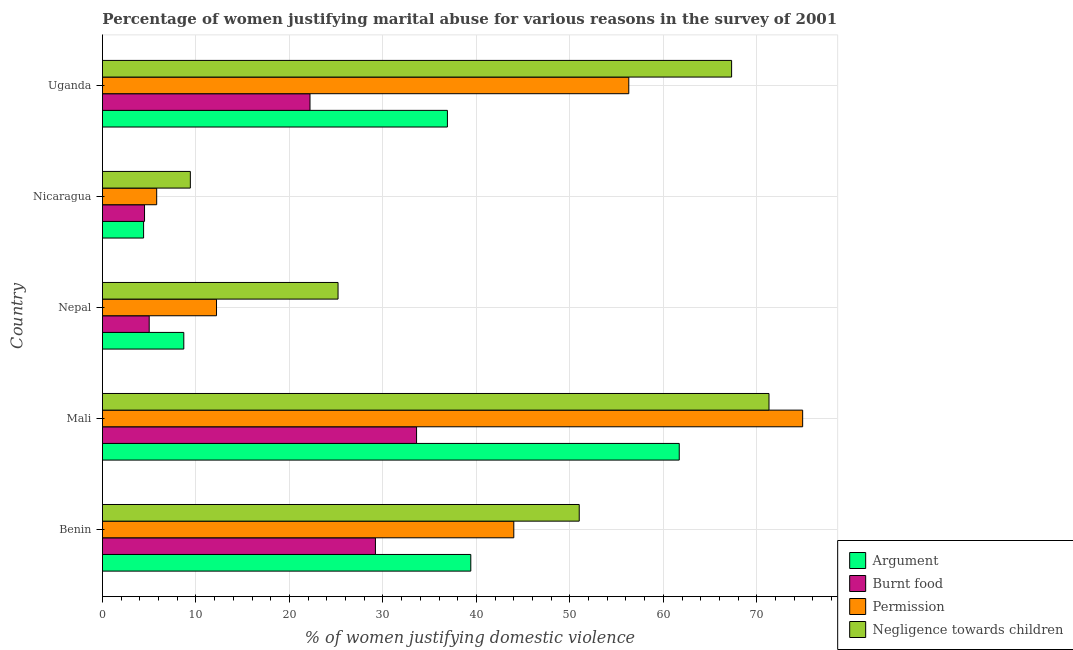How many groups of bars are there?
Provide a short and direct response. 5. Are the number of bars on each tick of the Y-axis equal?
Provide a short and direct response. Yes. How many bars are there on the 3rd tick from the top?
Your response must be concise. 4. What is the label of the 3rd group of bars from the top?
Offer a very short reply. Nepal. In how many cases, is the number of bars for a given country not equal to the number of legend labels?
Provide a short and direct response. 0. What is the percentage of women justifying abuse for showing negligence towards children in Nepal?
Provide a succinct answer. 25.2. Across all countries, what is the maximum percentage of women justifying abuse for going without permission?
Ensure brevity in your answer.  74.9. Across all countries, what is the minimum percentage of women justifying abuse for burning food?
Your answer should be very brief. 4.5. In which country was the percentage of women justifying abuse for going without permission maximum?
Make the answer very short. Mali. In which country was the percentage of women justifying abuse in the case of an argument minimum?
Offer a terse response. Nicaragua. What is the total percentage of women justifying abuse for going without permission in the graph?
Offer a terse response. 193.2. What is the difference between the percentage of women justifying abuse in the case of an argument in Nicaragua and that in Uganda?
Give a very brief answer. -32.5. What is the difference between the percentage of women justifying abuse for burning food in Benin and the percentage of women justifying abuse for going without permission in Nicaragua?
Offer a very short reply. 23.4. What is the average percentage of women justifying abuse for going without permission per country?
Keep it short and to the point. 38.64. What is the ratio of the percentage of women justifying abuse for burning food in Nepal to that in Nicaragua?
Ensure brevity in your answer.  1.11. Is the percentage of women justifying abuse for burning food in Benin less than that in Nicaragua?
Provide a succinct answer. No. What is the difference between the highest and the second highest percentage of women justifying abuse for burning food?
Provide a succinct answer. 4.4. What is the difference between the highest and the lowest percentage of women justifying abuse for going without permission?
Keep it short and to the point. 69.1. In how many countries, is the percentage of women justifying abuse in the case of an argument greater than the average percentage of women justifying abuse in the case of an argument taken over all countries?
Offer a very short reply. 3. What does the 3rd bar from the top in Mali represents?
Give a very brief answer. Burnt food. What does the 2nd bar from the bottom in Nicaragua represents?
Your response must be concise. Burnt food. Is it the case that in every country, the sum of the percentage of women justifying abuse in the case of an argument and percentage of women justifying abuse for burning food is greater than the percentage of women justifying abuse for going without permission?
Give a very brief answer. Yes. How many bars are there?
Offer a terse response. 20. Are all the bars in the graph horizontal?
Ensure brevity in your answer.  Yes. Does the graph contain grids?
Ensure brevity in your answer.  Yes. Where does the legend appear in the graph?
Keep it short and to the point. Bottom right. How many legend labels are there?
Give a very brief answer. 4. What is the title of the graph?
Make the answer very short. Percentage of women justifying marital abuse for various reasons in the survey of 2001. Does "Secondary schools" appear as one of the legend labels in the graph?
Offer a very short reply. No. What is the label or title of the X-axis?
Your response must be concise. % of women justifying domestic violence. What is the label or title of the Y-axis?
Keep it short and to the point. Country. What is the % of women justifying domestic violence of Argument in Benin?
Provide a short and direct response. 39.4. What is the % of women justifying domestic violence of Burnt food in Benin?
Offer a very short reply. 29.2. What is the % of women justifying domestic violence of Negligence towards children in Benin?
Offer a terse response. 51. What is the % of women justifying domestic violence of Argument in Mali?
Your answer should be compact. 61.7. What is the % of women justifying domestic violence of Burnt food in Mali?
Make the answer very short. 33.6. What is the % of women justifying domestic violence of Permission in Mali?
Keep it short and to the point. 74.9. What is the % of women justifying domestic violence of Negligence towards children in Mali?
Provide a succinct answer. 71.3. What is the % of women justifying domestic violence in Argument in Nepal?
Give a very brief answer. 8.7. What is the % of women justifying domestic violence in Negligence towards children in Nepal?
Make the answer very short. 25.2. What is the % of women justifying domestic violence of Argument in Nicaragua?
Give a very brief answer. 4.4. What is the % of women justifying domestic violence of Burnt food in Nicaragua?
Give a very brief answer. 4.5. What is the % of women justifying domestic violence of Permission in Nicaragua?
Make the answer very short. 5.8. What is the % of women justifying domestic violence in Argument in Uganda?
Keep it short and to the point. 36.9. What is the % of women justifying domestic violence in Burnt food in Uganda?
Give a very brief answer. 22.2. What is the % of women justifying domestic violence of Permission in Uganda?
Provide a succinct answer. 56.3. What is the % of women justifying domestic violence in Negligence towards children in Uganda?
Your response must be concise. 67.3. Across all countries, what is the maximum % of women justifying domestic violence of Argument?
Ensure brevity in your answer.  61.7. Across all countries, what is the maximum % of women justifying domestic violence in Burnt food?
Keep it short and to the point. 33.6. Across all countries, what is the maximum % of women justifying domestic violence in Permission?
Your answer should be compact. 74.9. Across all countries, what is the maximum % of women justifying domestic violence in Negligence towards children?
Your response must be concise. 71.3. Across all countries, what is the minimum % of women justifying domestic violence in Argument?
Provide a short and direct response. 4.4. Across all countries, what is the minimum % of women justifying domestic violence in Permission?
Your answer should be compact. 5.8. What is the total % of women justifying domestic violence of Argument in the graph?
Your answer should be very brief. 151.1. What is the total % of women justifying domestic violence of Burnt food in the graph?
Give a very brief answer. 94.5. What is the total % of women justifying domestic violence of Permission in the graph?
Give a very brief answer. 193.2. What is the total % of women justifying domestic violence of Negligence towards children in the graph?
Provide a succinct answer. 224.2. What is the difference between the % of women justifying domestic violence of Argument in Benin and that in Mali?
Provide a succinct answer. -22.3. What is the difference between the % of women justifying domestic violence in Burnt food in Benin and that in Mali?
Give a very brief answer. -4.4. What is the difference between the % of women justifying domestic violence in Permission in Benin and that in Mali?
Offer a terse response. -30.9. What is the difference between the % of women justifying domestic violence of Negligence towards children in Benin and that in Mali?
Your response must be concise. -20.3. What is the difference between the % of women justifying domestic violence of Argument in Benin and that in Nepal?
Ensure brevity in your answer.  30.7. What is the difference between the % of women justifying domestic violence of Burnt food in Benin and that in Nepal?
Offer a terse response. 24.2. What is the difference between the % of women justifying domestic violence of Permission in Benin and that in Nepal?
Your answer should be very brief. 31.8. What is the difference between the % of women justifying domestic violence in Negligence towards children in Benin and that in Nepal?
Your answer should be very brief. 25.8. What is the difference between the % of women justifying domestic violence of Argument in Benin and that in Nicaragua?
Make the answer very short. 35. What is the difference between the % of women justifying domestic violence in Burnt food in Benin and that in Nicaragua?
Ensure brevity in your answer.  24.7. What is the difference between the % of women justifying domestic violence of Permission in Benin and that in Nicaragua?
Your answer should be very brief. 38.2. What is the difference between the % of women justifying domestic violence of Negligence towards children in Benin and that in Nicaragua?
Give a very brief answer. 41.6. What is the difference between the % of women justifying domestic violence in Argument in Benin and that in Uganda?
Provide a short and direct response. 2.5. What is the difference between the % of women justifying domestic violence of Permission in Benin and that in Uganda?
Give a very brief answer. -12.3. What is the difference between the % of women justifying domestic violence of Negligence towards children in Benin and that in Uganda?
Offer a very short reply. -16.3. What is the difference between the % of women justifying domestic violence of Argument in Mali and that in Nepal?
Make the answer very short. 53. What is the difference between the % of women justifying domestic violence of Burnt food in Mali and that in Nepal?
Ensure brevity in your answer.  28.6. What is the difference between the % of women justifying domestic violence in Permission in Mali and that in Nepal?
Ensure brevity in your answer.  62.7. What is the difference between the % of women justifying domestic violence in Negligence towards children in Mali and that in Nepal?
Your answer should be very brief. 46.1. What is the difference between the % of women justifying domestic violence of Argument in Mali and that in Nicaragua?
Offer a very short reply. 57.3. What is the difference between the % of women justifying domestic violence in Burnt food in Mali and that in Nicaragua?
Ensure brevity in your answer.  29.1. What is the difference between the % of women justifying domestic violence of Permission in Mali and that in Nicaragua?
Keep it short and to the point. 69.1. What is the difference between the % of women justifying domestic violence in Negligence towards children in Mali and that in Nicaragua?
Provide a short and direct response. 61.9. What is the difference between the % of women justifying domestic violence in Argument in Mali and that in Uganda?
Offer a very short reply. 24.8. What is the difference between the % of women justifying domestic violence of Negligence towards children in Mali and that in Uganda?
Offer a terse response. 4. What is the difference between the % of women justifying domestic violence of Argument in Nepal and that in Nicaragua?
Make the answer very short. 4.3. What is the difference between the % of women justifying domestic violence in Permission in Nepal and that in Nicaragua?
Provide a short and direct response. 6.4. What is the difference between the % of women justifying domestic violence of Negligence towards children in Nepal and that in Nicaragua?
Make the answer very short. 15.8. What is the difference between the % of women justifying domestic violence in Argument in Nepal and that in Uganda?
Keep it short and to the point. -28.2. What is the difference between the % of women justifying domestic violence in Burnt food in Nepal and that in Uganda?
Your response must be concise. -17.2. What is the difference between the % of women justifying domestic violence of Permission in Nepal and that in Uganda?
Keep it short and to the point. -44.1. What is the difference between the % of women justifying domestic violence in Negligence towards children in Nepal and that in Uganda?
Provide a succinct answer. -42.1. What is the difference between the % of women justifying domestic violence in Argument in Nicaragua and that in Uganda?
Your answer should be very brief. -32.5. What is the difference between the % of women justifying domestic violence of Burnt food in Nicaragua and that in Uganda?
Offer a very short reply. -17.7. What is the difference between the % of women justifying domestic violence of Permission in Nicaragua and that in Uganda?
Provide a short and direct response. -50.5. What is the difference between the % of women justifying domestic violence of Negligence towards children in Nicaragua and that in Uganda?
Offer a terse response. -57.9. What is the difference between the % of women justifying domestic violence in Argument in Benin and the % of women justifying domestic violence in Burnt food in Mali?
Give a very brief answer. 5.8. What is the difference between the % of women justifying domestic violence of Argument in Benin and the % of women justifying domestic violence of Permission in Mali?
Offer a terse response. -35.5. What is the difference between the % of women justifying domestic violence in Argument in Benin and the % of women justifying domestic violence in Negligence towards children in Mali?
Keep it short and to the point. -31.9. What is the difference between the % of women justifying domestic violence of Burnt food in Benin and the % of women justifying domestic violence of Permission in Mali?
Offer a very short reply. -45.7. What is the difference between the % of women justifying domestic violence of Burnt food in Benin and the % of women justifying domestic violence of Negligence towards children in Mali?
Ensure brevity in your answer.  -42.1. What is the difference between the % of women justifying domestic violence in Permission in Benin and the % of women justifying domestic violence in Negligence towards children in Mali?
Offer a terse response. -27.3. What is the difference between the % of women justifying domestic violence in Argument in Benin and the % of women justifying domestic violence in Burnt food in Nepal?
Your answer should be very brief. 34.4. What is the difference between the % of women justifying domestic violence in Argument in Benin and the % of women justifying domestic violence in Permission in Nepal?
Ensure brevity in your answer.  27.2. What is the difference between the % of women justifying domestic violence in Burnt food in Benin and the % of women justifying domestic violence in Negligence towards children in Nepal?
Keep it short and to the point. 4. What is the difference between the % of women justifying domestic violence in Argument in Benin and the % of women justifying domestic violence in Burnt food in Nicaragua?
Provide a succinct answer. 34.9. What is the difference between the % of women justifying domestic violence in Argument in Benin and the % of women justifying domestic violence in Permission in Nicaragua?
Make the answer very short. 33.6. What is the difference between the % of women justifying domestic violence of Burnt food in Benin and the % of women justifying domestic violence of Permission in Nicaragua?
Offer a terse response. 23.4. What is the difference between the % of women justifying domestic violence in Burnt food in Benin and the % of women justifying domestic violence in Negligence towards children in Nicaragua?
Make the answer very short. 19.8. What is the difference between the % of women justifying domestic violence of Permission in Benin and the % of women justifying domestic violence of Negligence towards children in Nicaragua?
Provide a succinct answer. 34.6. What is the difference between the % of women justifying domestic violence of Argument in Benin and the % of women justifying domestic violence of Permission in Uganda?
Offer a very short reply. -16.9. What is the difference between the % of women justifying domestic violence in Argument in Benin and the % of women justifying domestic violence in Negligence towards children in Uganda?
Ensure brevity in your answer.  -27.9. What is the difference between the % of women justifying domestic violence of Burnt food in Benin and the % of women justifying domestic violence of Permission in Uganda?
Your answer should be compact. -27.1. What is the difference between the % of women justifying domestic violence of Burnt food in Benin and the % of women justifying domestic violence of Negligence towards children in Uganda?
Your response must be concise. -38.1. What is the difference between the % of women justifying domestic violence in Permission in Benin and the % of women justifying domestic violence in Negligence towards children in Uganda?
Give a very brief answer. -23.3. What is the difference between the % of women justifying domestic violence in Argument in Mali and the % of women justifying domestic violence in Burnt food in Nepal?
Offer a terse response. 56.7. What is the difference between the % of women justifying domestic violence of Argument in Mali and the % of women justifying domestic violence of Permission in Nepal?
Provide a succinct answer. 49.5. What is the difference between the % of women justifying domestic violence of Argument in Mali and the % of women justifying domestic violence of Negligence towards children in Nepal?
Provide a short and direct response. 36.5. What is the difference between the % of women justifying domestic violence of Burnt food in Mali and the % of women justifying domestic violence of Permission in Nepal?
Keep it short and to the point. 21.4. What is the difference between the % of women justifying domestic violence in Burnt food in Mali and the % of women justifying domestic violence in Negligence towards children in Nepal?
Offer a very short reply. 8.4. What is the difference between the % of women justifying domestic violence of Permission in Mali and the % of women justifying domestic violence of Negligence towards children in Nepal?
Provide a short and direct response. 49.7. What is the difference between the % of women justifying domestic violence in Argument in Mali and the % of women justifying domestic violence in Burnt food in Nicaragua?
Offer a terse response. 57.2. What is the difference between the % of women justifying domestic violence in Argument in Mali and the % of women justifying domestic violence in Permission in Nicaragua?
Your answer should be very brief. 55.9. What is the difference between the % of women justifying domestic violence in Argument in Mali and the % of women justifying domestic violence in Negligence towards children in Nicaragua?
Your answer should be compact. 52.3. What is the difference between the % of women justifying domestic violence in Burnt food in Mali and the % of women justifying domestic violence in Permission in Nicaragua?
Provide a succinct answer. 27.8. What is the difference between the % of women justifying domestic violence in Burnt food in Mali and the % of women justifying domestic violence in Negligence towards children in Nicaragua?
Provide a short and direct response. 24.2. What is the difference between the % of women justifying domestic violence of Permission in Mali and the % of women justifying domestic violence of Negligence towards children in Nicaragua?
Provide a succinct answer. 65.5. What is the difference between the % of women justifying domestic violence of Argument in Mali and the % of women justifying domestic violence of Burnt food in Uganda?
Keep it short and to the point. 39.5. What is the difference between the % of women justifying domestic violence in Burnt food in Mali and the % of women justifying domestic violence in Permission in Uganda?
Your answer should be compact. -22.7. What is the difference between the % of women justifying domestic violence of Burnt food in Mali and the % of women justifying domestic violence of Negligence towards children in Uganda?
Make the answer very short. -33.7. What is the difference between the % of women justifying domestic violence of Argument in Nepal and the % of women justifying domestic violence of Burnt food in Nicaragua?
Keep it short and to the point. 4.2. What is the difference between the % of women justifying domestic violence of Argument in Nepal and the % of women justifying domestic violence of Permission in Nicaragua?
Offer a very short reply. 2.9. What is the difference between the % of women justifying domestic violence in Argument in Nepal and the % of women justifying domestic violence in Negligence towards children in Nicaragua?
Keep it short and to the point. -0.7. What is the difference between the % of women justifying domestic violence of Burnt food in Nepal and the % of women justifying domestic violence of Negligence towards children in Nicaragua?
Your response must be concise. -4.4. What is the difference between the % of women justifying domestic violence in Argument in Nepal and the % of women justifying domestic violence in Burnt food in Uganda?
Your response must be concise. -13.5. What is the difference between the % of women justifying domestic violence of Argument in Nepal and the % of women justifying domestic violence of Permission in Uganda?
Offer a very short reply. -47.6. What is the difference between the % of women justifying domestic violence in Argument in Nepal and the % of women justifying domestic violence in Negligence towards children in Uganda?
Offer a very short reply. -58.6. What is the difference between the % of women justifying domestic violence in Burnt food in Nepal and the % of women justifying domestic violence in Permission in Uganda?
Offer a very short reply. -51.3. What is the difference between the % of women justifying domestic violence in Burnt food in Nepal and the % of women justifying domestic violence in Negligence towards children in Uganda?
Your answer should be compact. -62.3. What is the difference between the % of women justifying domestic violence in Permission in Nepal and the % of women justifying domestic violence in Negligence towards children in Uganda?
Ensure brevity in your answer.  -55.1. What is the difference between the % of women justifying domestic violence of Argument in Nicaragua and the % of women justifying domestic violence of Burnt food in Uganda?
Give a very brief answer. -17.8. What is the difference between the % of women justifying domestic violence of Argument in Nicaragua and the % of women justifying domestic violence of Permission in Uganda?
Ensure brevity in your answer.  -51.9. What is the difference between the % of women justifying domestic violence in Argument in Nicaragua and the % of women justifying domestic violence in Negligence towards children in Uganda?
Your answer should be very brief. -62.9. What is the difference between the % of women justifying domestic violence of Burnt food in Nicaragua and the % of women justifying domestic violence of Permission in Uganda?
Your answer should be compact. -51.8. What is the difference between the % of women justifying domestic violence of Burnt food in Nicaragua and the % of women justifying domestic violence of Negligence towards children in Uganda?
Your answer should be compact. -62.8. What is the difference between the % of women justifying domestic violence in Permission in Nicaragua and the % of women justifying domestic violence in Negligence towards children in Uganda?
Provide a short and direct response. -61.5. What is the average % of women justifying domestic violence in Argument per country?
Keep it short and to the point. 30.22. What is the average % of women justifying domestic violence of Burnt food per country?
Ensure brevity in your answer.  18.9. What is the average % of women justifying domestic violence of Permission per country?
Your answer should be very brief. 38.64. What is the average % of women justifying domestic violence in Negligence towards children per country?
Offer a terse response. 44.84. What is the difference between the % of women justifying domestic violence of Argument and % of women justifying domestic violence of Permission in Benin?
Keep it short and to the point. -4.6. What is the difference between the % of women justifying domestic violence in Burnt food and % of women justifying domestic violence in Permission in Benin?
Offer a very short reply. -14.8. What is the difference between the % of women justifying domestic violence in Burnt food and % of women justifying domestic violence in Negligence towards children in Benin?
Make the answer very short. -21.8. What is the difference between the % of women justifying domestic violence in Argument and % of women justifying domestic violence in Burnt food in Mali?
Ensure brevity in your answer.  28.1. What is the difference between the % of women justifying domestic violence of Argument and % of women justifying domestic violence of Permission in Mali?
Provide a short and direct response. -13.2. What is the difference between the % of women justifying domestic violence of Burnt food and % of women justifying domestic violence of Permission in Mali?
Your answer should be very brief. -41.3. What is the difference between the % of women justifying domestic violence in Burnt food and % of women justifying domestic violence in Negligence towards children in Mali?
Give a very brief answer. -37.7. What is the difference between the % of women justifying domestic violence in Argument and % of women justifying domestic violence in Burnt food in Nepal?
Offer a very short reply. 3.7. What is the difference between the % of women justifying domestic violence of Argument and % of women justifying domestic violence of Permission in Nepal?
Provide a succinct answer. -3.5. What is the difference between the % of women justifying domestic violence in Argument and % of women justifying domestic violence in Negligence towards children in Nepal?
Keep it short and to the point. -16.5. What is the difference between the % of women justifying domestic violence in Burnt food and % of women justifying domestic violence in Negligence towards children in Nepal?
Give a very brief answer. -20.2. What is the difference between the % of women justifying domestic violence in Permission and % of women justifying domestic violence in Negligence towards children in Nepal?
Make the answer very short. -13. What is the difference between the % of women justifying domestic violence of Burnt food and % of women justifying domestic violence of Negligence towards children in Nicaragua?
Your answer should be very brief. -4.9. What is the difference between the % of women justifying domestic violence in Permission and % of women justifying domestic violence in Negligence towards children in Nicaragua?
Provide a succinct answer. -3.6. What is the difference between the % of women justifying domestic violence in Argument and % of women justifying domestic violence in Permission in Uganda?
Offer a terse response. -19.4. What is the difference between the % of women justifying domestic violence of Argument and % of women justifying domestic violence of Negligence towards children in Uganda?
Provide a short and direct response. -30.4. What is the difference between the % of women justifying domestic violence in Burnt food and % of women justifying domestic violence in Permission in Uganda?
Provide a short and direct response. -34.1. What is the difference between the % of women justifying domestic violence of Burnt food and % of women justifying domestic violence of Negligence towards children in Uganda?
Make the answer very short. -45.1. What is the difference between the % of women justifying domestic violence of Permission and % of women justifying domestic violence of Negligence towards children in Uganda?
Give a very brief answer. -11. What is the ratio of the % of women justifying domestic violence in Argument in Benin to that in Mali?
Offer a very short reply. 0.64. What is the ratio of the % of women justifying domestic violence in Burnt food in Benin to that in Mali?
Keep it short and to the point. 0.87. What is the ratio of the % of women justifying domestic violence in Permission in Benin to that in Mali?
Your answer should be compact. 0.59. What is the ratio of the % of women justifying domestic violence of Negligence towards children in Benin to that in Mali?
Ensure brevity in your answer.  0.72. What is the ratio of the % of women justifying domestic violence in Argument in Benin to that in Nepal?
Give a very brief answer. 4.53. What is the ratio of the % of women justifying domestic violence in Burnt food in Benin to that in Nepal?
Your answer should be compact. 5.84. What is the ratio of the % of women justifying domestic violence of Permission in Benin to that in Nepal?
Offer a very short reply. 3.61. What is the ratio of the % of women justifying domestic violence in Negligence towards children in Benin to that in Nepal?
Give a very brief answer. 2.02. What is the ratio of the % of women justifying domestic violence in Argument in Benin to that in Nicaragua?
Make the answer very short. 8.95. What is the ratio of the % of women justifying domestic violence of Burnt food in Benin to that in Nicaragua?
Give a very brief answer. 6.49. What is the ratio of the % of women justifying domestic violence of Permission in Benin to that in Nicaragua?
Ensure brevity in your answer.  7.59. What is the ratio of the % of women justifying domestic violence in Negligence towards children in Benin to that in Nicaragua?
Offer a terse response. 5.43. What is the ratio of the % of women justifying domestic violence in Argument in Benin to that in Uganda?
Ensure brevity in your answer.  1.07. What is the ratio of the % of women justifying domestic violence in Burnt food in Benin to that in Uganda?
Give a very brief answer. 1.32. What is the ratio of the % of women justifying domestic violence of Permission in Benin to that in Uganda?
Your response must be concise. 0.78. What is the ratio of the % of women justifying domestic violence of Negligence towards children in Benin to that in Uganda?
Provide a short and direct response. 0.76. What is the ratio of the % of women justifying domestic violence in Argument in Mali to that in Nepal?
Make the answer very short. 7.09. What is the ratio of the % of women justifying domestic violence in Burnt food in Mali to that in Nepal?
Your response must be concise. 6.72. What is the ratio of the % of women justifying domestic violence in Permission in Mali to that in Nepal?
Provide a succinct answer. 6.14. What is the ratio of the % of women justifying domestic violence in Negligence towards children in Mali to that in Nepal?
Keep it short and to the point. 2.83. What is the ratio of the % of women justifying domestic violence of Argument in Mali to that in Nicaragua?
Give a very brief answer. 14.02. What is the ratio of the % of women justifying domestic violence of Burnt food in Mali to that in Nicaragua?
Your answer should be compact. 7.47. What is the ratio of the % of women justifying domestic violence in Permission in Mali to that in Nicaragua?
Ensure brevity in your answer.  12.91. What is the ratio of the % of women justifying domestic violence in Negligence towards children in Mali to that in Nicaragua?
Offer a terse response. 7.59. What is the ratio of the % of women justifying domestic violence of Argument in Mali to that in Uganda?
Your answer should be compact. 1.67. What is the ratio of the % of women justifying domestic violence of Burnt food in Mali to that in Uganda?
Offer a terse response. 1.51. What is the ratio of the % of women justifying domestic violence in Permission in Mali to that in Uganda?
Provide a short and direct response. 1.33. What is the ratio of the % of women justifying domestic violence of Negligence towards children in Mali to that in Uganda?
Give a very brief answer. 1.06. What is the ratio of the % of women justifying domestic violence of Argument in Nepal to that in Nicaragua?
Your answer should be compact. 1.98. What is the ratio of the % of women justifying domestic violence of Permission in Nepal to that in Nicaragua?
Provide a succinct answer. 2.1. What is the ratio of the % of women justifying domestic violence of Negligence towards children in Nepal to that in Nicaragua?
Your answer should be compact. 2.68. What is the ratio of the % of women justifying domestic violence in Argument in Nepal to that in Uganda?
Give a very brief answer. 0.24. What is the ratio of the % of women justifying domestic violence in Burnt food in Nepal to that in Uganda?
Offer a terse response. 0.23. What is the ratio of the % of women justifying domestic violence in Permission in Nepal to that in Uganda?
Provide a succinct answer. 0.22. What is the ratio of the % of women justifying domestic violence of Negligence towards children in Nepal to that in Uganda?
Offer a very short reply. 0.37. What is the ratio of the % of women justifying domestic violence in Argument in Nicaragua to that in Uganda?
Your answer should be very brief. 0.12. What is the ratio of the % of women justifying domestic violence in Burnt food in Nicaragua to that in Uganda?
Give a very brief answer. 0.2. What is the ratio of the % of women justifying domestic violence of Permission in Nicaragua to that in Uganda?
Provide a succinct answer. 0.1. What is the ratio of the % of women justifying domestic violence of Negligence towards children in Nicaragua to that in Uganda?
Keep it short and to the point. 0.14. What is the difference between the highest and the second highest % of women justifying domestic violence of Argument?
Offer a very short reply. 22.3. What is the difference between the highest and the second highest % of women justifying domestic violence of Burnt food?
Keep it short and to the point. 4.4. What is the difference between the highest and the lowest % of women justifying domestic violence in Argument?
Your response must be concise. 57.3. What is the difference between the highest and the lowest % of women justifying domestic violence of Burnt food?
Offer a very short reply. 29.1. What is the difference between the highest and the lowest % of women justifying domestic violence of Permission?
Give a very brief answer. 69.1. What is the difference between the highest and the lowest % of women justifying domestic violence of Negligence towards children?
Keep it short and to the point. 61.9. 